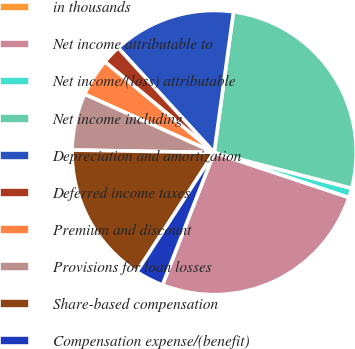<chart> <loc_0><loc_0><loc_500><loc_500><pie_chart><fcel>in thousands<fcel>Net income attributable to<fcel>Net income/(loss) attributable<fcel>Net income including<fcel>Depreciation and amortization<fcel>Deferred income taxes<fcel>Premium and discount<fcel>Provisions for loan losses<fcel>Share-based compensation<fcel>Compensation expense/(benefit)<nl><fcel>0.01%<fcel>25.8%<fcel>1.08%<fcel>26.87%<fcel>13.98%<fcel>2.16%<fcel>4.3%<fcel>6.45%<fcel>16.13%<fcel>3.23%<nl></chart> 